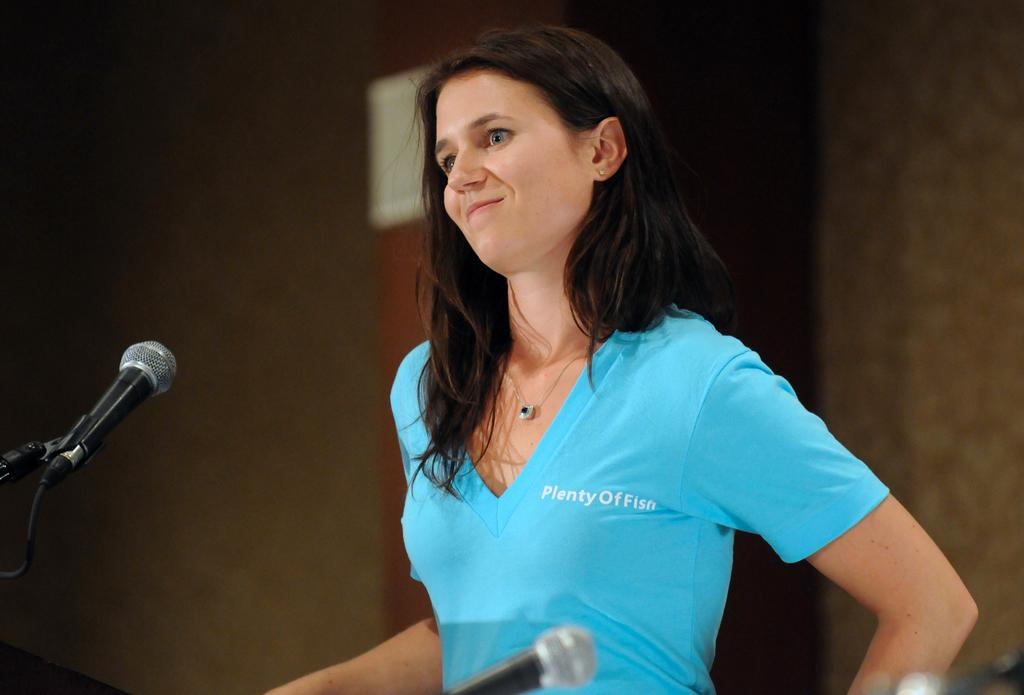What is the main subject of the image? There is a woman standing in the image. What is the woman wearing in the image? The woman is wearing a blue T-shirt. What objects can be seen in the image besides the woman? There are microphones in the image. Can you describe the background of the image? The background of the image is blurred. What type of trade is being conducted in the image? There is no indication of any trade being conducted in the image; it primarily features a woman standing with microphones nearby. How many feet can be seen in the image? The number of feet visible in the image cannot be determined, as the focus is on the woman's upper body and the microphones. 